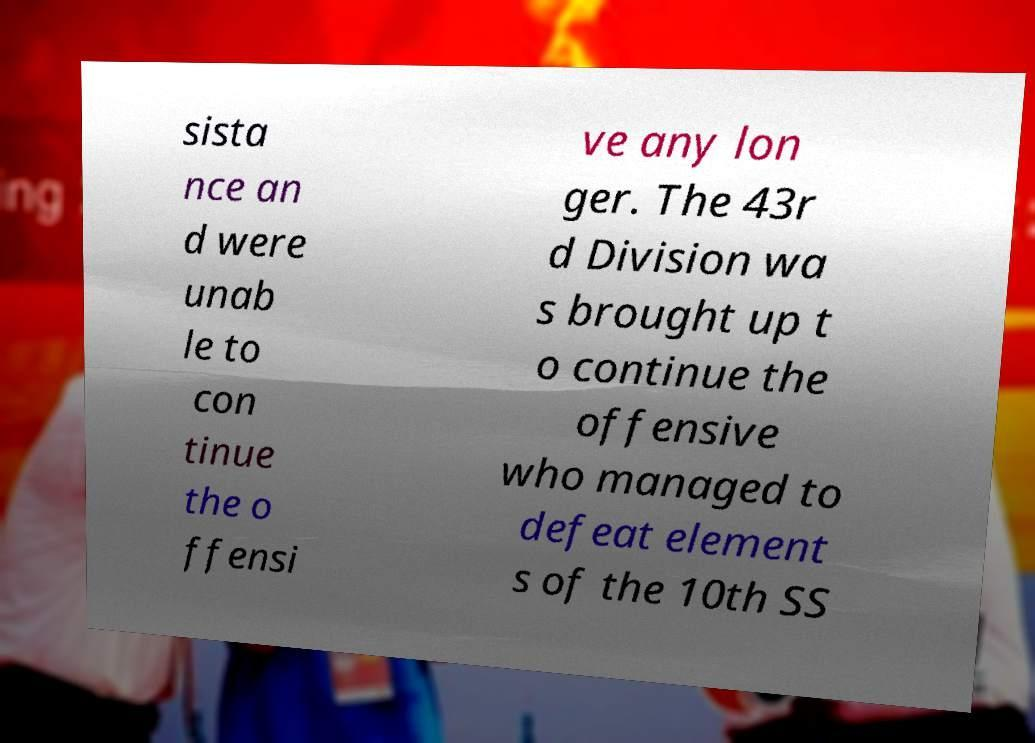Can you read and provide the text displayed in the image?This photo seems to have some interesting text. Can you extract and type it out for me? sista nce an d were unab le to con tinue the o ffensi ve any lon ger. The 43r d Division wa s brought up t o continue the offensive who managed to defeat element s of the 10th SS 